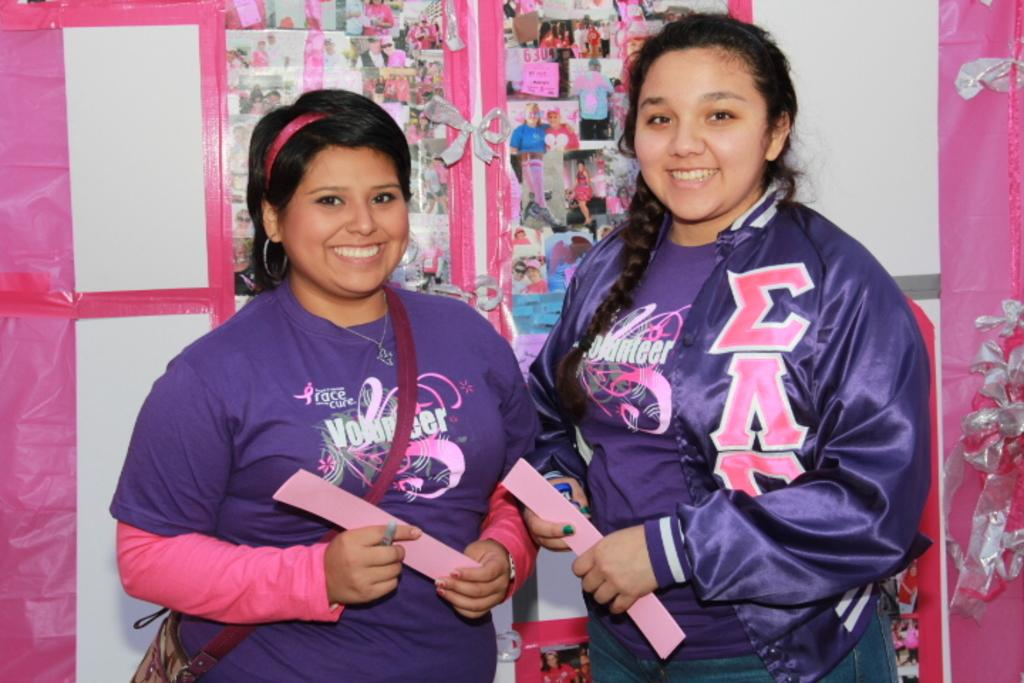<image>
Write a terse but informative summary of the picture. a couple girls in a room with the word race on one of their shirts 